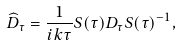Convert formula to latex. <formula><loc_0><loc_0><loc_500><loc_500>\widehat { D } _ { \tau } = \frac { 1 } { i k \tau } S ( \tau ) D _ { \tau } S ( \tau ) ^ { - 1 } ,</formula> 